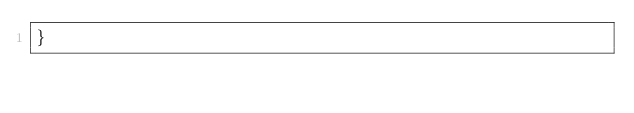<code> <loc_0><loc_0><loc_500><loc_500><_Scala_>}
</code> 